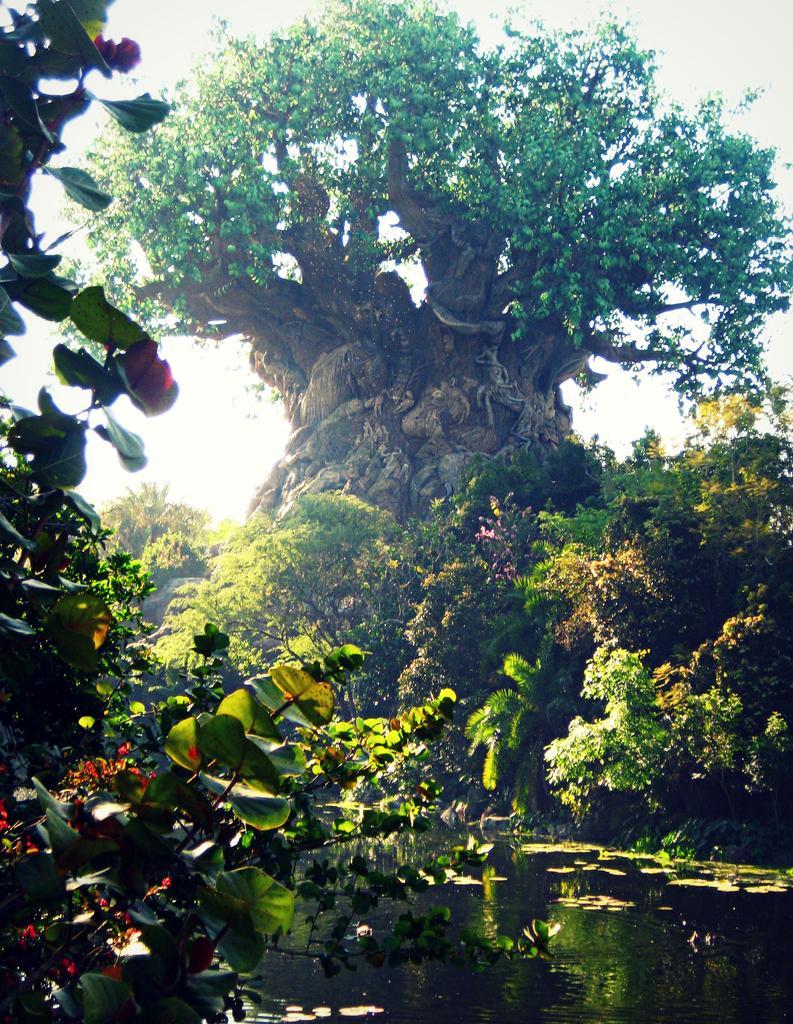Could you give a brief overview of what you see in this image? In this image we can see a group of trees and plants. At the bottom we can see water and in the water, there are few leaves. At the top we can see the sky. 